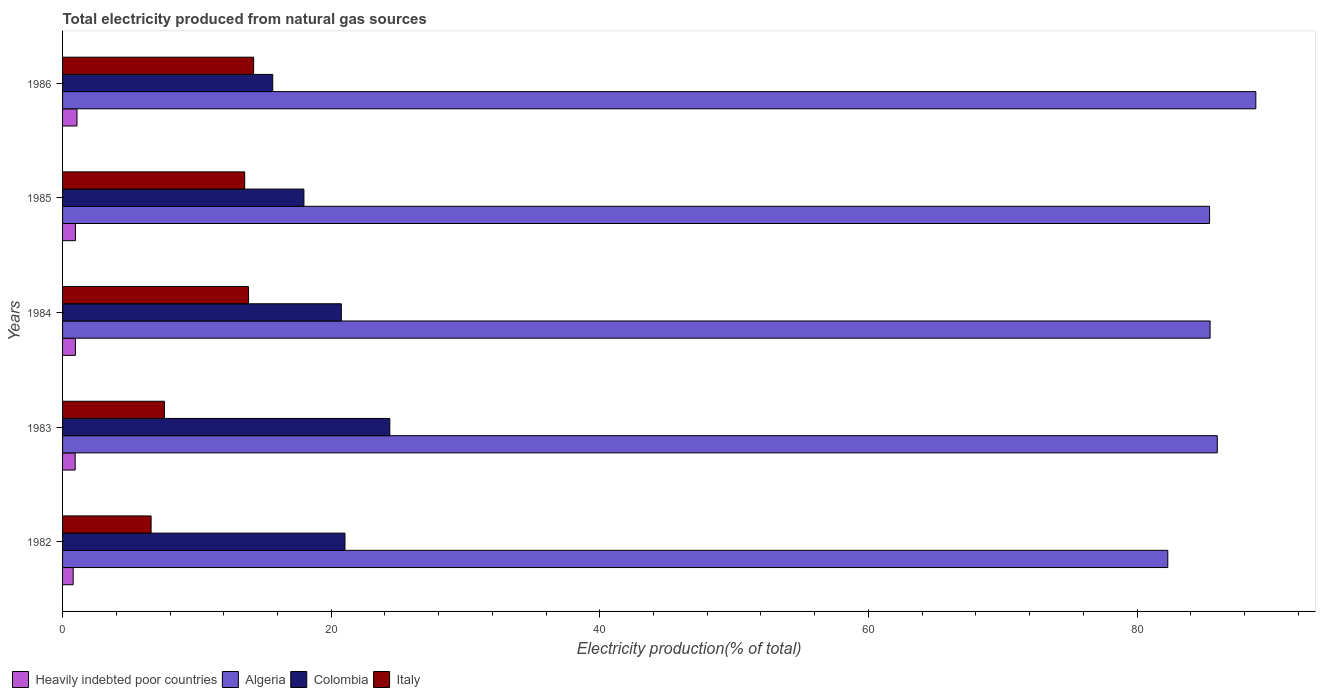How many different coloured bars are there?
Keep it short and to the point. 4. Are the number of bars on each tick of the Y-axis equal?
Your answer should be very brief. Yes. How many bars are there on the 3rd tick from the top?
Your answer should be compact. 4. How many bars are there on the 2nd tick from the bottom?
Offer a terse response. 4. What is the total electricity produced in Algeria in 1985?
Offer a very short reply. 85.4. Across all years, what is the maximum total electricity produced in Colombia?
Offer a very short reply. 24.37. Across all years, what is the minimum total electricity produced in Heavily indebted poor countries?
Offer a terse response. 0.79. In which year was the total electricity produced in Italy maximum?
Give a very brief answer. 1986. In which year was the total electricity produced in Italy minimum?
Give a very brief answer. 1982. What is the total total electricity produced in Colombia in the graph?
Make the answer very short. 99.77. What is the difference between the total electricity produced in Colombia in 1985 and that in 1986?
Keep it short and to the point. 2.32. What is the difference between the total electricity produced in Italy in 1983 and the total electricity produced in Heavily indebted poor countries in 1984?
Your response must be concise. 6.63. What is the average total electricity produced in Heavily indebted poor countries per year?
Your answer should be very brief. 0.94. In the year 1982, what is the difference between the total electricity produced in Colombia and total electricity produced in Algeria?
Give a very brief answer. -61.26. In how many years, is the total electricity produced in Algeria greater than 20 %?
Ensure brevity in your answer.  5. What is the ratio of the total electricity produced in Heavily indebted poor countries in 1982 to that in 1986?
Your answer should be very brief. 0.74. Is the total electricity produced in Italy in 1985 less than that in 1986?
Offer a terse response. Yes. Is the difference between the total electricity produced in Colombia in 1983 and 1984 greater than the difference between the total electricity produced in Algeria in 1983 and 1984?
Make the answer very short. Yes. What is the difference between the highest and the second highest total electricity produced in Algeria?
Give a very brief answer. 2.87. What is the difference between the highest and the lowest total electricity produced in Italy?
Keep it short and to the point. 7.63. In how many years, is the total electricity produced in Heavily indebted poor countries greater than the average total electricity produced in Heavily indebted poor countries taken over all years?
Your answer should be very brief. 3. What does the 2nd bar from the top in 1985 represents?
Offer a terse response. Colombia. What does the 1st bar from the bottom in 1985 represents?
Your answer should be compact. Heavily indebted poor countries. How many years are there in the graph?
Keep it short and to the point. 5. Where does the legend appear in the graph?
Offer a terse response. Bottom left. What is the title of the graph?
Your answer should be compact. Total electricity produced from natural gas sources. What is the label or title of the Y-axis?
Make the answer very short. Years. What is the Electricity production(% of total) of Heavily indebted poor countries in 1982?
Provide a short and direct response. 0.79. What is the Electricity production(% of total) in Algeria in 1982?
Keep it short and to the point. 82.29. What is the Electricity production(% of total) of Colombia in 1982?
Provide a succinct answer. 21.03. What is the Electricity production(% of total) of Italy in 1982?
Offer a terse response. 6.59. What is the Electricity production(% of total) of Heavily indebted poor countries in 1983?
Your answer should be compact. 0.94. What is the Electricity production(% of total) in Algeria in 1983?
Provide a short and direct response. 85.98. What is the Electricity production(% of total) in Colombia in 1983?
Make the answer very short. 24.37. What is the Electricity production(% of total) in Italy in 1983?
Offer a terse response. 7.58. What is the Electricity production(% of total) in Heavily indebted poor countries in 1984?
Give a very brief answer. 0.96. What is the Electricity production(% of total) of Algeria in 1984?
Provide a succinct answer. 85.44. What is the Electricity production(% of total) of Colombia in 1984?
Your response must be concise. 20.76. What is the Electricity production(% of total) of Italy in 1984?
Your response must be concise. 13.85. What is the Electricity production(% of total) of Heavily indebted poor countries in 1985?
Ensure brevity in your answer.  0.96. What is the Electricity production(% of total) of Algeria in 1985?
Provide a succinct answer. 85.4. What is the Electricity production(% of total) in Colombia in 1985?
Keep it short and to the point. 17.97. What is the Electricity production(% of total) in Italy in 1985?
Keep it short and to the point. 13.56. What is the Electricity production(% of total) of Heavily indebted poor countries in 1986?
Ensure brevity in your answer.  1.07. What is the Electricity production(% of total) of Algeria in 1986?
Make the answer very short. 88.85. What is the Electricity production(% of total) in Colombia in 1986?
Offer a very short reply. 15.65. What is the Electricity production(% of total) of Italy in 1986?
Keep it short and to the point. 14.23. Across all years, what is the maximum Electricity production(% of total) in Heavily indebted poor countries?
Give a very brief answer. 1.07. Across all years, what is the maximum Electricity production(% of total) in Algeria?
Your answer should be very brief. 88.85. Across all years, what is the maximum Electricity production(% of total) of Colombia?
Offer a terse response. 24.37. Across all years, what is the maximum Electricity production(% of total) in Italy?
Give a very brief answer. 14.23. Across all years, what is the minimum Electricity production(% of total) in Heavily indebted poor countries?
Offer a terse response. 0.79. Across all years, what is the minimum Electricity production(% of total) of Algeria?
Provide a succinct answer. 82.29. Across all years, what is the minimum Electricity production(% of total) in Colombia?
Your answer should be compact. 15.65. Across all years, what is the minimum Electricity production(% of total) in Italy?
Ensure brevity in your answer.  6.59. What is the total Electricity production(% of total) in Heavily indebted poor countries in the graph?
Make the answer very short. 4.72. What is the total Electricity production(% of total) of Algeria in the graph?
Provide a short and direct response. 427.95. What is the total Electricity production(% of total) of Colombia in the graph?
Provide a succinct answer. 99.77. What is the total Electricity production(% of total) of Italy in the graph?
Ensure brevity in your answer.  55.8. What is the difference between the Electricity production(% of total) of Heavily indebted poor countries in 1982 and that in 1983?
Keep it short and to the point. -0.15. What is the difference between the Electricity production(% of total) of Algeria in 1982 and that in 1983?
Keep it short and to the point. -3.69. What is the difference between the Electricity production(% of total) of Colombia in 1982 and that in 1983?
Keep it short and to the point. -3.34. What is the difference between the Electricity production(% of total) in Italy in 1982 and that in 1983?
Provide a succinct answer. -0.99. What is the difference between the Electricity production(% of total) of Heavily indebted poor countries in 1982 and that in 1984?
Make the answer very short. -0.16. What is the difference between the Electricity production(% of total) of Algeria in 1982 and that in 1984?
Give a very brief answer. -3.15. What is the difference between the Electricity production(% of total) in Colombia in 1982 and that in 1984?
Offer a very short reply. 0.27. What is the difference between the Electricity production(% of total) in Italy in 1982 and that in 1984?
Ensure brevity in your answer.  -7.26. What is the difference between the Electricity production(% of total) in Heavily indebted poor countries in 1982 and that in 1985?
Ensure brevity in your answer.  -0.17. What is the difference between the Electricity production(% of total) of Algeria in 1982 and that in 1985?
Provide a succinct answer. -3.11. What is the difference between the Electricity production(% of total) in Colombia in 1982 and that in 1985?
Provide a short and direct response. 3.06. What is the difference between the Electricity production(% of total) in Italy in 1982 and that in 1985?
Ensure brevity in your answer.  -6.97. What is the difference between the Electricity production(% of total) of Heavily indebted poor countries in 1982 and that in 1986?
Offer a very short reply. -0.28. What is the difference between the Electricity production(% of total) in Algeria in 1982 and that in 1986?
Offer a very short reply. -6.55. What is the difference between the Electricity production(% of total) of Colombia in 1982 and that in 1986?
Provide a succinct answer. 5.38. What is the difference between the Electricity production(% of total) of Italy in 1982 and that in 1986?
Offer a terse response. -7.63. What is the difference between the Electricity production(% of total) of Heavily indebted poor countries in 1983 and that in 1984?
Your answer should be compact. -0.02. What is the difference between the Electricity production(% of total) in Algeria in 1983 and that in 1984?
Give a very brief answer. 0.53. What is the difference between the Electricity production(% of total) in Colombia in 1983 and that in 1984?
Make the answer very short. 3.61. What is the difference between the Electricity production(% of total) of Italy in 1983 and that in 1984?
Make the answer very short. -6.27. What is the difference between the Electricity production(% of total) of Heavily indebted poor countries in 1983 and that in 1985?
Offer a terse response. -0.02. What is the difference between the Electricity production(% of total) of Algeria in 1983 and that in 1985?
Ensure brevity in your answer.  0.58. What is the difference between the Electricity production(% of total) of Colombia in 1983 and that in 1985?
Your answer should be very brief. 6.4. What is the difference between the Electricity production(% of total) of Italy in 1983 and that in 1985?
Your answer should be very brief. -5.98. What is the difference between the Electricity production(% of total) in Heavily indebted poor countries in 1983 and that in 1986?
Ensure brevity in your answer.  -0.14. What is the difference between the Electricity production(% of total) in Algeria in 1983 and that in 1986?
Your response must be concise. -2.87. What is the difference between the Electricity production(% of total) of Colombia in 1983 and that in 1986?
Keep it short and to the point. 8.72. What is the difference between the Electricity production(% of total) in Italy in 1983 and that in 1986?
Ensure brevity in your answer.  -6.64. What is the difference between the Electricity production(% of total) in Heavily indebted poor countries in 1984 and that in 1985?
Provide a succinct answer. -0. What is the difference between the Electricity production(% of total) of Algeria in 1984 and that in 1985?
Offer a terse response. 0.04. What is the difference between the Electricity production(% of total) in Colombia in 1984 and that in 1985?
Give a very brief answer. 2.79. What is the difference between the Electricity production(% of total) in Italy in 1984 and that in 1985?
Give a very brief answer. 0.29. What is the difference between the Electricity production(% of total) in Heavily indebted poor countries in 1984 and that in 1986?
Ensure brevity in your answer.  -0.12. What is the difference between the Electricity production(% of total) in Algeria in 1984 and that in 1986?
Offer a terse response. -3.4. What is the difference between the Electricity production(% of total) of Colombia in 1984 and that in 1986?
Your response must be concise. 5.11. What is the difference between the Electricity production(% of total) in Italy in 1984 and that in 1986?
Ensure brevity in your answer.  -0.38. What is the difference between the Electricity production(% of total) in Heavily indebted poor countries in 1985 and that in 1986?
Provide a succinct answer. -0.12. What is the difference between the Electricity production(% of total) in Algeria in 1985 and that in 1986?
Your answer should be very brief. -3.45. What is the difference between the Electricity production(% of total) of Colombia in 1985 and that in 1986?
Offer a terse response. 2.32. What is the difference between the Electricity production(% of total) in Italy in 1985 and that in 1986?
Your answer should be compact. -0.67. What is the difference between the Electricity production(% of total) of Heavily indebted poor countries in 1982 and the Electricity production(% of total) of Algeria in 1983?
Provide a succinct answer. -85.18. What is the difference between the Electricity production(% of total) in Heavily indebted poor countries in 1982 and the Electricity production(% of total) in Colombia in 1983?
Your answer should be very brief. -23.57. What is the difference between the Electricity production(% of total) of Heavily indebted poor countries in 1982 and the Electricity production(% of total) of Italy in 1983?
Give a very brief answer. -6.79. What is the difference between the Electricity production(% of total) in Algeria in 1982 and the Electricity production(% of total) in Colombia in 1983?
Offer a very short reply. 57.92. What is the difference between the Electricity production(% of total) in Algeria in 1982 and the Electricity production(% of total) in Italy in 1983?
Provide a short and direct response. 74.71. What is the difference between the Electricity production(% of total) in Colombia in 1982 and the Electricity production(% of total) in Italy in 1983?
Provide a short and direct response. 13.45. What is the difference between the Electricity production(% of total) of Heavily indebted poor countries in 1982 and the Electricity production(% of total) of Algeria in 1984?
Keep it short and to the point. -84.65. What is the difference between the Electricity production(% of total) in Heavily indebted poor countries in 1982 and the Electricity production(% of total) in Colombia in 1984?
Your answer should be compact. -19.96. What is the difference between the Electricity production(% of total) in Heavily indebted poor countries in 1982 and the Electricity production(% of total) in Italy in 1984?
Give a very brief answer. -13.06. What is the difference between the Electricity production(% of total) of Algeria in 1982 and the Electricity production(% of total) of Colombia in 1984?
Your answer should be very brief. 61.53. What is the difference between the Electricity production(% of total) of Algeria in 1982 and the Electricity production(% of total) of Italy in 1984?
Keep it short and to the point. 68.44. What is the difference between the Electricity production(% of total) of Colombia in 1982 and the Electricity production(% of total) of Italy in 1984?
Provide a succinct answer. 7.18. What is the difference between the Electricity production(% of total) in Heavily indebted poor countries in 1982 and the Electricity production(% of total) in Algeria in 1985?
Offer a very short reply. -84.61. What is the difference between the Electricity production(% of total) in Heavily indebted poor countries in 1982 and the Electricity production(% of total) in Colombia in 1985?
Provide a succinct answer. -17.18. What is the difference between the Electricity production(% of total) in Heavily indebted poor countries in 1982 and the Electricity production(% of total) in Italy in 1985?
Make the answer very short. -12.77. What is the difference between the Electricity production(% of total) of Algeria in 1982 and the Electricity production(% of total) of Colombia in 1985?
Your response must be concise. 64.32. What is the difference between the Electricity production(% of total) of Algeria in 1982 and the Electricity production(% of total) of Italy in 1985?
Your answer should be very brief. 68.73. What is the difference between the Electricity production(% of total) in Colombia in 1982 and the Electricity production(% of total) in Italy in 1985?
Provide a short and direct response. 7.47. What is the difference between the Electricity production(% of total) in Heavily indebted poor countries in 1982 and the Electricity production(% of total) in Algeria in 1986?
Your response must be concise. -88.05. What is the difference between the Electricity production(% of total) of Heavily indebted poor countries in 1982 and the Electricity production(% of total) of Colombia in 1986?
Your response must be concise. -14.86. What is the difference between the Electricity production(% of total) of Heavily indebted poor countries in 1982 and the Electricity production(% of total) of Italy in 1986?
Ensure brevity in your answer.  -13.43. What is the difference between the Electricity production(% of total) in Algeria in 1982 and the Electricity production(% of total) in Colombia in 1986?
Ensure brevity in your answer.  66.64. What is the difference between the Electricity production(% of total) of Algeria in 1982 and the Electricity production(% of total) of Italy in 1986?
Provide a short and direct response. 68.06. What is the difference between the Electricity production(% of total) in Colombia in 1982 and the Electricity production(% of total) in Italy in 1986?
Your response must be concise. 6.8. What is the difference between the Electricity production(% of total) in Heavily indebted poor countries in 1983 and the Electricity production(% of total) in Algeria in 1984?
Offer a very short reply. -84.5. What is the difference between the Electricity production(% of total) in Heavily indebted poor countries in 1983 and the Electricity production(% of total) in Colombia in 1984?
Give a very brief answer. -19.82. What is the difference between the Electricity production(% of total) in Heavily indebted poor countries in 1983 and the Electricity production(% of total) in Italy in 1984?
Your answer should be very brief. -12.91. What is the difference between the Electricity production(% of total) in Algeria in 1983 and the Electricity production(% of total) in Colombia in 1984?
Keep it short and to the point. 65.22. What is the difference between the Electricity production(% of total) in Algeria in 1983 and the Electricity production(% of total) in Italy in 1984?
Provide a succinct answer. 72.13. What is the difference between the Electricity production(% of total) of Colombia in 1983 and the Electricity production(% of total) of Italy in 1984?
Offer a terse response. 10.52. What is the difference between the Electricity production(% of total) in Heavily indebted poor countries in 1983 and the Electricity production(% of total) in Algeria in 1985?
Make the answer very short. -84.46. What is the difference between the Electricity production(% of total) in Heavily indebted poor countries in 1983 and the Electricity production(% of total) in Colombia in 1985?
Give a very brief answer. -17.03. What is the difference between the Electricity production(% of total) in Heavily indebted poor countries in 1983 and the Electricity production(% of total) in Italy in 1985?
Offer a terse response. -12.62. What is the difference between the Electricity production(% of total) in Algeria in 1983 and the Electricity production(% of total) in Colombia in 1985?
Keep it short and to the point. 68. What is the difference between the Electricity production(% of total) of Algeria in 1983 and the Electricity production(% of total) of Italy in 1985?
Ensure brevity in your answer.  72.42. What is the difference between the Electricity production(% of total) in Colombia in 1983 and the Electricity production(% of total) in Italy in 1985?
Provide a succinct answer. 10.81. What is the difference between the Electricity production(% of total) in Heavily indebted poor countries in 1983 and the Electricity production(% of total) in Algeria in 1986?
Provide a short and direct response. -87.91. What is the difference between the Electricity production(% of total) of Heavily indebted poor countries in 1983 and the Electricity production(% of total) of Colombia in 1986?
Provide a succinct answer. -14.71. What is the difference between the Electricity production(% of total) in Heavily indebted poor countries in 1983 and the Electricity production(% of total) in Italy in 1986?
Make the answer very short. -13.29. What is the difference between the Electricity production(% of total) in Algeria in 1983 and the Electricity production(% of total) in Colombia in 1986?
Offer a very short reply. 70.33. What is the difference between the Electricity production(% of total) in Algeria in 1983 and the Electricity production(% of total) in Italy in 1986?
Provide a short and direct response. 71.75. What is the difference between the Electricity production(% of total) of Colombia in 1983 and the Electricity production(% of total) of Italy in 1986?
Provide a short and direct response. 10.14. What is the difference between the Electricity production(% of total) of Heavily indebted poor countries in 1984 and the Electricity production(% of total) of Algeria in 1985?
Provide a short and direct response. -84.44. What is the difference between the Electricity production(% of total) of Heavily indebted poor countries in 1984 and the Electricity production(% of total) of Colombia in 1985?
Your answer should be very brief. -17.02. What is the difference between the Electricity production(% of total) of Heavily indebted poor countries in 1984 and the Electricity production(% of total) of Italy in 1985?
Your answer should be compact. -12.61. What is the difference between the Electricity production(% of total) in Algeria in 1984 and the Electricity production(% of total) in Colombia in 1985?
Your response must be concise. 67.47. What is the difference between the Electricity production(% of total) of Algeria in 1984 and the Electricity production(% of total) of Italy in 1985?
Give a very brief answer. 71.88. What is the difference between the Electricity production(% of total) of Colombia in 1984 and the Electricity production(% of total) of Italy in 1985?
Offer a terse response. 7.2. What is the difference between the Electricity production(% of total) of Heavily indebted poor countries in 1984 and the Electricity production(% of total) of Algeria in 1986?
Keep it short and to the point. -87.89. What is the difference between the Electricity production(% of total) in Heavily indebted poor countries in 1984 and the Electricity production(% of total) in Colombia in 1986?
Keep it short and to the point. -14.69. What is the difference between the Electricity production(% of total) of Heavily indebted poor countries in 1984 and the Electricity production(% of total) of Italy in 1986?
Provide a succinct answer. -13.27. What is the difference between the Electricity production(% of total) in Algeria in 1984 and the Electricity production(% of total) in Colombia in 1986?
Provide a short and direct response. 69.79. What is the difference between the Electricity production(% of total) in Algeria in 1984 and the Electricity production(% of total) in Italy in 1986?
Make the answer very short. 71.22. What is the difference between the Electricity production(% of total) of Colombia in 1984 and the Electricity production(% of total) of Italy in 1986?
Provide a short and direct response. 6.53. What is the difference between the Electricity production(% of total) in Heavily indebted poor countries in 1985 and the Electricity production(% of total) in Algeria in 1986?
Make the answer very short. -87.89. What is the difference between the Electricity production(% of total) of Heavily indebted poor countries in 1985 and the Electricity production(% of total) of Colombia in 1986?
Keep it short and to the point. -14.69. What is the difference between the Electricity production(% of total) in Heavily indebted poor countries in 1985 and the Electricity production(% of total) in Italy in 1986?
Offer a terse response. -13.27. What is the difference between the Electricity production(% of total) of Algeria in 1985 and the Electricity production(% of total) of Colombia in 1986?
Make the answer very short. 69.75. What is the difference between the Electricity production(% of total) in Algeria in 1985 and the Electricity production(% of total) in Italy in 1986?
Offer a terse response. 71.17. What is the difference between the Electricity production(% of total) in Colombia in 1985 and the Electricity production(% of total) in Italy in 1986?
Your answer should be very brief. 3.75. What is the average Electricity production(% of total) in Heavily indebted poor countries per year?
Your answer should be compact. 0.94. What is the average Electricity production(% of total) in Algeria per year?
Give a very brief answer. 85.59. What is the average Electricity production(% of total) of Colombia per year?
Ensure brevity in your answer.  19.95. What is the average Electricity production(% of total) of Italy per year?
Your answer should be compact. 11.16. In the year 1982, what is the difference between the Electricity production(% of total) in Heavily indebted poor countries and Electricity production(% of total) in Algeria?
Offer a terse response. -81.5. In the year 1982, what is the difference between the Electricity production(% of total) in Heavily indebted poor countries and Electricity production(% of total) in Colombia?
Give a very brief answer. -20.24. In the year 1982, what is the difference between the Electricity production(% of total) of Heavily indebted poor countries and Electricity production(% of total) of Italy?
Your answer should be compact. -5.8. In the year 1982, what is the difference between the Electricity production(% of total) of Algeria and Electricity production(% of total) of Colombia?
Provide a short and direct response. 61.26. In the year 1982, what is the difference between the Electricity production(% of total) of Algeria and Electricity production(% of total) of Italy?
Give a very brief answer. 75.7. In the year 1982, what is the difference between the Electricity production(% of total) of Colombia and Electricity production(% of total) of Italy?
Make the answer very short. 14.43. In the year 1983, what is the difference between the Electricity production(% of total) of Heavily indebted poor countries and Electricity production(% of total) of Algeria?
Your answer should be compact. -85.04. In the year 1983, what is the difference between the Electricity production(% of total) of Heavily indebted poor countries and Electricity production(% of total) of Colombia?
Keep it short and to the point. -23.43. In the year 1983, what is the difference between the Electricity production(% of total) in Heavily indebted poor countries and Electricity production(% of total) in Italy?
Ensure brevity in your answer.  -6.64. In the year 1983, what is the difference between the Electricity production(% of total) of Algeria and Electricity production(% of total) of Colombia?
Offer a terse response. 61.61. In the year 1983, what is the difference between the Electricity production(% of total) of Algeria and Electricity production(% of total) of Italy?
Offer a terse response. 78.39. In the year 1983, what is the difference between the Electricity production(% of total) of Colombia and Electricity production(% of total) of Italy?
Provide a succinct answer. 16.78. In the year 1984, what is the difference between the Electricity production(% of total) in Heavily indebted poor countries and Electricity production(% of total) in Algeria?
Your answer should be compact. -84.49. In the year 1984, what is the difference between the Electricity production(% of total) of Heavily indebted poor countries and Electricity production(% of total) of Colombia?
Make the answer very short. -19.8. In the year 1984, what is the difference between the Electricity production(% of total) in Heavily indebted poor countries and Electricity production(% of total) in Italy?
Give a very brief answer. -12.89. In the year 1984, what is the difference between the Electricity production(% of total) in Algeria and Electricity production(% of total) in Colombia?
Offer a terse response. 64.69. In the year 1984, what is the difference between the Electricity production(% of total) in Algeria and Electricity production(% of total) in Italy?
Your answer should be compact. 71.59. In the year 1984, what is the difference between the Electricity production(% of total) in Colombia and Electricity production(% of total) in Italy?
Keep it short and to the point. 6.91. In the year 1985, what is the difference between the Electricity production(% of total) in Heavily indebted poor countries and Electricity production(% of total) in Algeria?
Your response must be concise. -84.44. In the year 1985, what is the difference between the Electricity production(% of total) of Heavily indebted poor countries and Electricity production(% of total) of Colombia?
Ensure brevity in your answer.  -17.01. In the year 1985, what is the difference between the Electricity production(% of total) in Heavily indebted poor countries and Electricity production(% of total) in Italy?
Give a very brief answer. -12.6. In the year 1985, what is the difference between the Electricity production(% of total) in Algeria and Electricity production(% of total) in Colombia?
Your response must be concise. 67.43. In the year 1985, what is the difference between the Electricity production(% of total) in Algeria and Electricity production(% of total) in Italy?
Provide a short and direct response. 71.84. In the year 1985, what is the difference between the Electricity production(% of total) in Colombia and Electricity production(% of total) in Italy?
Your answer should be compact. 4.41. In the year 1986, what is the difference between the Electricity production(% of total) of Heavily indebted poor countries and Electricity production(% of total) of Algeria?
Your response must be concise. -87.77. In the year 1986, what is the difference between the Electricity production(% of total) in Heavily indebted poor countries and Electricity production(% of total) in Colombia?
Your answer should be compact. -14.57. In the year 1986, what is the difference between the Electricity production(% of total) of Heavily indebted poor countries and Electricity production(% of total) of Italy?
Keep it short and to the point. -13.15. In the year 1986, what is the difference between the Electricity production(% of total) in Algeria and Electricity production(% of total) in Colombia?
Your response must be concise. 73.2. In the year 1986, what is the difference between the Electricity production(% of total) of Algeria and Electricity production(% of total) of Italy?
Keep it short and to the point. 74.62. In the year 1986, what is the difference between the Electricity production(% of total) of Colombia and Electricity production(% of total) of Italy?
Ensure brevity in your answer.  1.42. What is the ratio of the Electricity production(% of total) in Heavily indebted poor countries in 1982 to that in 1983?
Your answer should be very brief. 0.84. What is the ratio of the Electricity production(% of total) in Algeria in 1982 to that in 1983?
Your answer should be very brief. 0.96. What is the ratio of the Electricity production(% of total) of Colombia in 1982 to that in 1983?
Your response must be concise. 0.86. What is the ratio of the Electricity production(% of total) of Italy in 1982 to that in 1983?
Provide a short and direct response. 0.87. What is the ratio of the Electricity production(% of total) of Heavily indebted poor countries in 1982 to that in 1984?
Your response must be concise. 0.83. What is the ratio of the Electricity production(% of total) in Algeria in 1982 to that in 1984?
Keep it short and to the point. 0.96. What is the ratio of the Electricity production(% of total) in Italy in 1982 to that in 1984?
Offer a very short reply. 0.48. What is the ratio of the Electricity production(% of total) in Heavily indebted poor countries in 1982 to that in 1985?
Offer a terse response. 0.83. What is the ratio of the Electricity production(% of total) of Algeria in 1982 to that in 1985?
Your answer should be very brief. 0.96. What is the ratio of the Electricity production(% of total) of Colombia in 1982 to that in 1985?
Your answer should be very brief. 1.17. What is the ratio of the Electricity production(% of total) of Italy in 1982 to that in 1985?
Your response must be concise. 0.49. What is the ratio of the Electricity production(% of total) in Heavily indebted poor countries in 1982 to that in 1986?
Make the answer very short. 0.74. What is the ratio of the Electricity production(% of total) in Algeria in 1982 to that in 1986?
Make the answer very short. 0.93. What is the ratio of the Electricity production(% of total) in Colombia in 1982 to that in 1986?
Provide a short and direct response. 1.34. What is the ratio of the Electricity production(% of total) of Italy in 1982 to that in 1986?
Give a very brief answer. 0.46. What is the ratio of the Electricity production(% of total) in Heavily indebted poor countries in 1983 to that in 1984?
Ensure brevity in your answer.  0.98. What is the ratio of the Electricity production(% of total) of Algeria in 1983 to that in 1984?
Keep it short and to the point. 1.01. What is the ratio of the Electricity production(% of total) of Colombia in 1983 to that in 1984?
Offer a terse response. 1.17. What is the ratio of the Electricity production(% of total) in Italy in 1983 to that in 1984?
Offer a very short reply. 0.55. What is the ratio of the Electricity production(% of total) in Heavily indebted poor countries in 1983 to that in 1985?
Ensure brevity in your answer.  0.98. What is the ratio of the Electricity production(% of total) of Colombia in 1983 to that in 1985?
Your answer should be compact. 1.36. What is the ratio of the Electricity production(% of total) in Italy in 1983 to that in 1985?
Your answer should be compact. 0.56. What is the ratio of the Electricity production(% of total) in Heavily indebted poor countries in 1983 to that in 1986?
Provide a succinct answer. 0.87. What is the ratio of the Electricity production(% of total) in Colombia in 1983 to that in 1986?
Offer a very short reply. 1.56. What is the ratio of the Electricity production(% of total) of Italy in 1983 to that in 1986?
Your answer should be very brief. 0.53. What is the ratio of the Electricity production(% of total) of Colombia in 1984 to that in 1985?
Make the answer very short. 1.16. What is the ratio of the Electricity production(% of total) in Italy in 1984 to that in 1985?
Make the answer very short. 1.02. What is the ratio of the Electricity production(% of total) in Heavily indebted poor countries in 1984 to that in 1986?
Offer a terse response. 0.89. What is the ratio of the Electricity production(% of total) of Algeria in 1984 to that in 1986?
Provide a succinct answer. 0.96. What is the ratio of the Electricity production(% of total) of Colombia in 1984 to that in 1986?
Your answer should be compact. 1.33. What is the ratio of the Electricity production(% of total) in Italy in 1984 to that in 1986?
Offer a terse response. 0.97. What is the ratio of the Electricity production(% of total) in Heavily indebted poor countries in 1985 to that in 1986?
Offer a terse response. 0.89. What is the ratio of the Electricity production(% of total) of Algeria in 1985 to that in 1986?
Your response must be concise. 0.96. What is the ratio of the Electricity production(% of total) in Colombia in 1985 to that in 1986?
Keep it short and to the point. 1.15. What is the ratio of the Electricity production(% of total) of Italy in 1985 to that in 1986?
Ensure brevity in your answer.  0.95. What is the difference between the highest and the second highest Electricity production(% of total) in Heavily indebted poor countries?
Provide a short and direct response. 0.12. What is the difference between the highest and the second highest Electricity production(% of total) in Algeria?
Offer a terse response. 2.87. What is the difference between the highest and the second highest Electricity production(% of total) in Colombia?
Offer a very short reply. 3.34. What is the difference between the highest and the second highest Electricity production(% of total) of Italy?
Your answer should be compact. 0.38. What is the difference between the highest and the lowest Electricity production(% of total) in Heavily indebted poor countries?
Your answer should be very brief. 0.28. What is the difference between the highest and the lowest Electricity production(% of total) in Algeria?
Your response must be concise. 6.55. What is the difference between the highest and the lowest Electricity production(% of total) of Colombia?
Your answer should be compact. 8.72. What is the difference between the highest and the lowest Electricity production(% of total) in Italy?
Give a very brief answer. 7.63. 